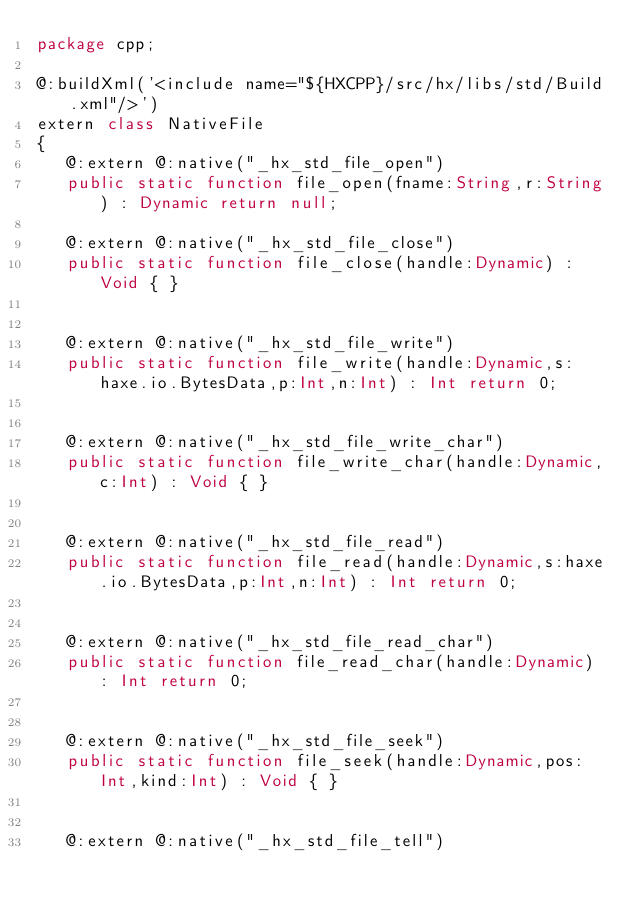Convert code to text. <code><loc_0><loc_0><loc_500><loc_500><_Haxe_>package cpp;

@:buildXml('<include name="${HXCPP}/src/hx/libs/std/Build.xml"/>')
extern class NativeFile
{
   @:extern @:native("_hx_std_file_open")
   public static function file_open(fname:String,r:String) : Dynamic return null;

   @:extern @:native("_hx_std_file_close")
   public static function file_close(handle:Dynamic) : Void { }


   @:extern @:native("_hx_std_file_write")
   public static function file_write(handle:Dynamic,s:haxe.io.BytesData,p:Int,n:Int) : Int return 0;


   @:extern @:native("_hx_std_file_write_char")
   public static function file_write_char(handle:Dynamic,c:Int) : Void { }


   @:extern @:native("_hx_std_file_read")
   public static function file_read(handle:Dynamic,s:haxe.io.BytesData,p:Int,n:Int) : Int return 0;


   @:extern @:native("_hx_std_file_read_char")
   public static function file_read_char(handle:Dynamic) : Int return 0;


   @:extern @:native("_hx_std_file_seek")
   public static function file_seek(handle:Dynamic,pos:Int,kind:Int) : Void { }


   @:extern @:native("_hx_std_file_tell")</code> 